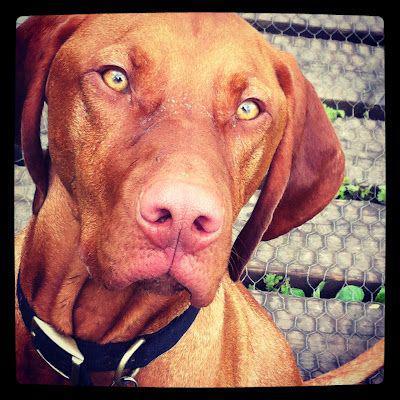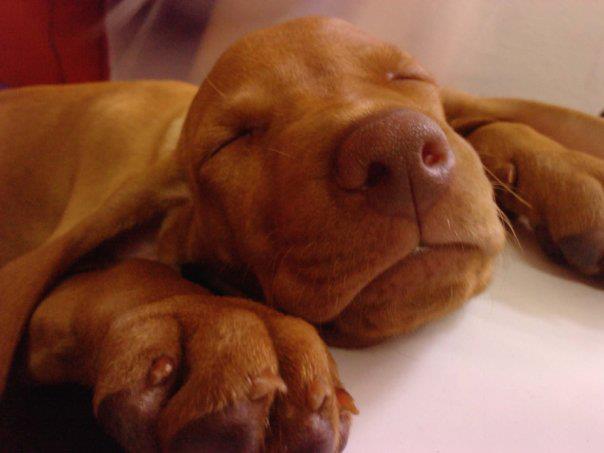The first image is the image on the left, the second image is the image on the right. Examine the images to the left and right. Is the description "A dog is laying on its stomach in the right image." accurate? Answer yes or no. Yes. The first image is the image on the left, the second image is the image on the right. Evaluate the accuracy of this statement regarding the images: "The left image shows one dog gazing with an upright head, and the right image shows a dog reclining with its front paws forward and its head rightside-up.". Is it true? Answer yes or no. Yes. 